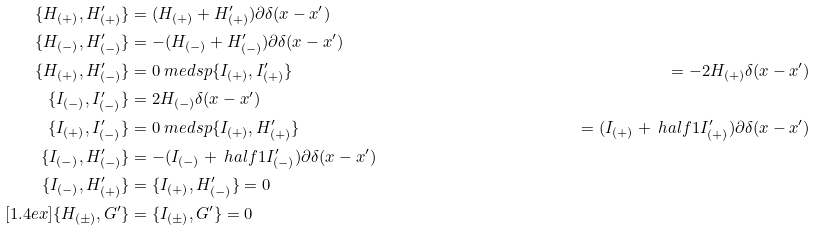Convert formula to latex. <formula><loc_0><loc_0><loc_500><loc_500>\{ H _ { ( + ) } , H ^ { \prime } _ { ( + ) } \} & = ( H _ { ( + ) } + H ^ { \prime } _ { ( + ) } ) \partial \delta ( x - x ^ { \prime } ) \\ \{ H _ { ( - ) } , H ^ { \prime } _ { ( - ) } \} & = - ( H _ { ( - ) } + H ^ { \prime } _ { ( - ) } ) \partial \delta ( x - x ^ { \prime } ) \\ \{ H _ { ( + ) } , H ^ { \prime } _ { ( - ) } \} & = 0 \ m e d s p \{ I _ { ( + ) } , I ^ { \prime } _ { ( + ) } \} & = - 2 H _ { ( + ) } \delta ( x - x ^ { \prime } ) \\ \{ I _ { ( - ) } , I ^ { \prime } _ { ( - ) } \} & = 2 H _ { ( - ) } \delta ( x - x ^ { \prime } ) \\ \{ I _ { ( + ) } , I ^ { \prime } _ { ( - ) } \} & = 0 \ m e d s p \{ I _ { ( + ) } , H ^ { \prime } _ { ( + ) } \} & = ( I _ { ( + ) } + \ h a l f { 1 } I ^ { \prime } _ { ( + ) } ) \partial \delta ( x - x ^ { \prime } ) \\ \{ I _ { ( - ) } , H ^ { \prime } _ { ( - ) } \} & = - ( I _ { ( - ) } + \ h a l f { 1 } I ^ { \prime } _ { ( - ) } ) \partial \delta ( x - x ^ { \prime } ) \\ \{ I _ { ( - ) } , H ^ { \prime } _ { ( + ) } \} & = \{ I _ { ( + ) } , H ^ { \prime } _ { ( - ) } \} = 0 \\ [ 1 . 4 e x ] \{ H _ { ( \pm ) } , G ^ { \prime } \} & = \{ I _ { ( \pm ) } , G ^ { \prime } \} = 0</formula> 